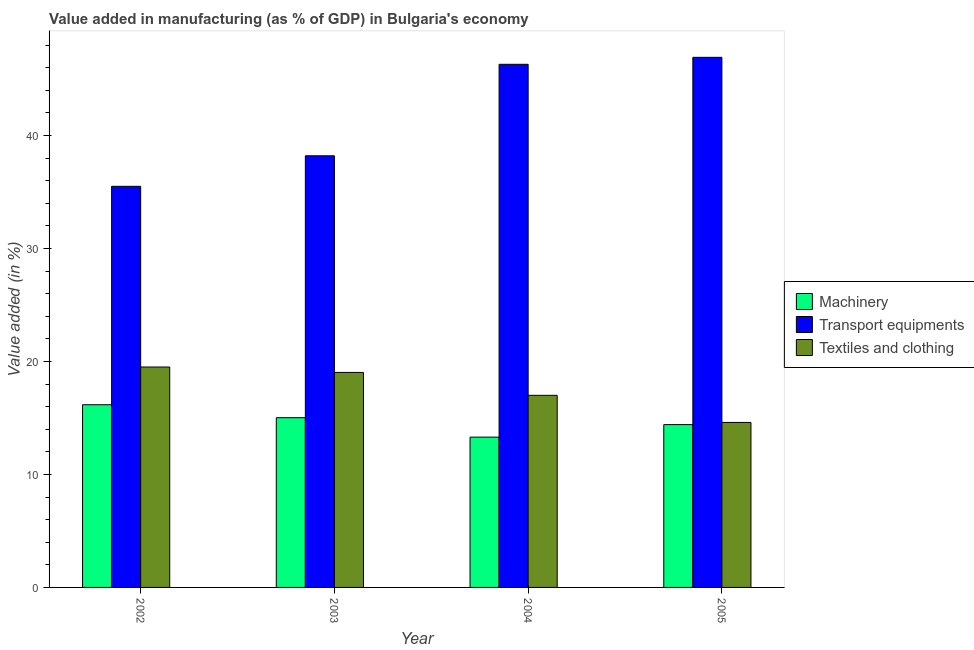Are the number of bars per tick equal to the number of legend labels?
Your response must be concise. Yes. What is the value added in manufacturing transport equipments in 2004?
Provide a succinct answer. 46.3. Across all years, what is the maximum value added in manufacturing transport equipments?
Your answer should be compact. 46.92. Across all years, what is the minimum value added in manufacturing textile and clothing?
Your answer should be compact. 14.6. What is the total value added in manufacturing machinery in the graph?
Provide a short and direct response. 58.9. What is the difference between the value added in manufacturing transport equipments in 2002 and that in 2005?
Your response must be concise. -11.42. What is the difference between the value added in manufacturing textile and clothing in 2003 and the value added in manufacturing machinery in 2005?
Keep it short and to the point. 4.42. What is the average value added in manufacturing transport equipments per year?
Make the answer very short. 41.73. In the year 2002, what is the difference between the value added in manufacturing machinery and value added in manufacturing textile and clothing?
Your answer should be very brief. 0. What is the ratio of the value added in manufacturing transport equipments in 2004 to that in 2005?
Keep it short and to the point. 0.99. What is the difference between the highest and the second highest value added in manufacturing transport equipments?
Provide a succinct answer. 0.62. What is the difference between the highest and the lowest value added in manufacturing transport equipments?
Provide a succinct answer. 11.42. In how many years, is the value added in manufacturing machinery greater than the average value added in manufacturing machinery taken over all years?
Give a very brief answer. 2. Is the sum of the value added in manufacturing machinery in 2003 and 2004 greater than the maximum value added in manufacturing transport equipments across all years?
Offer a terse response. Yes. What does the 1st bar from the left in 2005 represents?
Your answer should be compact. Machinery. What does the 3rd bar from the right in 2005 represents?
Offer a terse response. Machinery. Are all the bars in the graph horizontal?
Offer a terse response. No. How many years are there in the graph?
Make the answer very short. 4. What is the difference between two consecutive major ticks on the Y-axis?
Offer a very short reply. 10. Does the graph contain any zero values?
Keep it short and to the point. No. Where does the legend appear in the graph?
Make the answer very short. Center right. What is the title of the graph?
Your answer should be compact. Value added in manufacturing (as % of GDP) in Bulgaria's economy. Does "Nuclear sources" appear as one of the legend labels in the graph?
Make the answer very short. No. What is the label or title of the X-axis?
Keep it short and to the point. Year. What is the label or title of the Y-axis?
Give a very brief answer. Value added (in %). What is the Value added (in %) in Machinery in 2002?
Give a very brief answer. 16.17. What is the Value added (in %) of Transport equipments in 2002?
Your answer should be very brief. 35.5. What is the Value added (in %) of Textiles and clothing in 2002?
Offer a very short reply. 19.51. What is the Value added (in %) in Machinery in 2003?
Keep it short and to the point. 15.02. What is the Value added (in %) of Transport equipments in 2003?
Keep it short and to the point. 38.2. What is the Value added (in %) of Textiles and clothing in 2003?
Give a very brief answer. 19.03. What is the Value added (in %) of Machinery in 2004?
Offer a very short reply. 13.3. What is the Value added (in %) of Transport equipments in 2004?
Your answer should be compact. 46.3. What is the Value added (in %) in Textiles and clothing in 2004?
Make the answer very short. 17. What is the Value added (in %) of Machinery in 2005?
Give a very brief answer. 14.41. What is the Value added (in %) in Transport equipments in 2005?
Your answer should be compact. 46.92. What is the Value added (in %) in Textiles and clothing in 2005?
Offer a terse response. 14.6. Across all years, what is the maximum Value added (in %) in Machinery?
Keep it short and to the point. 16.17. Across all years, what is the maximum Value added (in %) of Transport equipments?
Offer a terse response. 46.92. Across all years, what is the maximum Value added (in %) in Textiles and clothing?
Provide a succinct answer. 19.51. Across all years, what is the minimum Value added (in %) of Machinery?
Keep it short and to the point. 13.3. Across all years, what is the minimum Value added (in %) of Transport equipments?
Provide a succinct answer. 35.5. Across all years, what is the minimum Value added (in %) in Textiles and clothing?
Provide a short and direct response. 14.6. What is the total Value added (in %) of Machinery in the graph?
Your answer should be compact. 58.9. What is the total Value added (in %) of Transport equipments in the graph?
Your response must be concise. 166.92. What is the total Value added (in %) in Textiles and clothing in the graph?
Your answer should be very brief. 70.14. What is the difference between the Value added (in %) of Machinery in 2002 and that in 2003?
Your answer should be compact. 1.15. What is the difference between the Value added (in %) of Transport equipments in 2002 and that in 2003?
Offer a terse response. -2.7. What is the difference between the Value added (in %) in Textiles and clothing in 2002 and that in 2003?
Make the answer very short. 0.48. What is the difference between the Value added (in %) in Machinery in 2002 and that in 2004?
Offer a very short reply. 2.87. What is the difference between the Value added (in %) in Transport equipments in 2002 and that in 2004?
Ensure brevity in your answer.  -10.8. What is the difference between the Value added (in %) of Textiles and clothing in 2002 and that in 2004?
Offer a very short reply. 2.51. What is the difference between the Value added (in %) of Machinery in 2002 and that in 2005?
Offer a terse response. 1.76. What is the difference between the Value added (in %) in Transport equipments in 2002 and that in 2005?
Make the answer very short. -11.42. What is the difference between the Value added (in %) in Textiles and clothing in 2002 and that in 2005?
Keep it short and to the point. 4.9. What is the difference between the Value added (in %) in Machinery in 2003 and that in 2004?
Your answer should be compact. 1.72. What is the difference between the Value added (in %) in Transport equipments in 2003 and that in 2004?
Keep it short and to the point. -8.1. What is the difference between the Value added (in %) in Textiles and clothing in 2003 and that in 2004?
Offer a very short reply. 2.03. What is the difference between the Value added (in %) in Machinery in 2003 and that in 2005?
Your answer should be very brief. 0.61. What is the difference between the Value added (in %) of Transport equipments in 2003 and that in 2005?
Provide a succinct answer. -8.71. What is the difference between the Value added (in %) of Textiles and clothing in 2003 and that in 2005?
Your answer should be very brief. 4.42. What is the difference between the Value added (in %) in Machinery in 2004 and that in 2005?
Offer a very short reply. -1.11. What is the difference between the Value added (in %) of Transport equipments in 2004 and that in 2005?
Make the answer very short. -0.62. What is the difference between the Value added (in %) in Textiles and clothing in 2004 and that in 2005?
Your answer should be compact. 2.4. What is the difference between the Value added (in %) in Machinery in 2002 and the Value added (in %) in Transport equipments in 2003?
Your response must be concise. -22.03. What is the difference between the Value added (in %) of Machinery in 2002 and the Value added (in %) of Textiles and clothing in 2003?
Your answer should be compact. -2.86. What is the difference between the Value added (in %) of Transport equipments in 2002 and the Value added (in %) of Textiles and clothing in 2003?
Make the answer very short. 16.47. What is the difference between the Value added (in %) in Machinery in 2002 and the Value added (in %) in Transport equipments in 2004?
Offer a terse response. -30.13. What is the difference between the Value added (in %) of Machinery in 2002 and the Value added (in %) of Textiles and clothing in 2004?
Give a very brief answer. -0.83. What is the difference between the Value added (in %) of Transport equipments in 2002 and the Value added (in %) of Textiles and clothing in 2004?
Provide a short and direct response. 18.5. What is the difference between the Value added (in %) in Machinery in 2002 and the Value added (in %) in Transport equipments in 2005?
Your answer should be compact. -30.75. What is the difference between the Value added (in %) in Machinery in 2002 and the Value added (in %) in Textiles and clothing in 2005?
Your answer should be very brief. 1.57. What is the difference between the Value added (in %) of Transport equipments in 2002 and the Value added (in %) of Textiles and clothing in 2005?
Make the answer very short. 20.9. What is the difference between the Value added (in %) of Machinery in 2003 and the Value added (in %) of Transport equipments in 2004?
Your answer should be very brief. -31.28. What is the difference between the Value added (in %) of Machinery in 2003 and the Value added (in %) of Textiles and clothing in 2004?
Your response must be concise. -1.98. What is the difference between the Value added (in %) of Transport equipments in 2003 and the Value added (in %) of Textiles and clothing in 2004?
Make the answer very short. 21.2. What is the difference between the Value added (in %) of Machinery in 2003 and the Value added (in %) of Transport equipments in 2005?
Your answer should be very brief. -31.89. What is the difference between the Value added (in %) in Machinery in 2003 and the Value added (in %) in Textiles and clothing in 2005?
Provide a short and direct response. 0.42. What is the difference between the Value added (in %) in Transport equipments in 2003 and the Value added (in %) in Textiles and clothing in 2005?
Provide a succinct answer. 23.6. What is the difference between the Value added (in %) of Machinery in 2004 and the Value added (in %) of Transport equipments in 2005?
Your answer should be very brief. -33.62. What is the difference between the Value added (in %) in Machinery in 2004 and the Value added (in %) in Textiles and clothing in 2005?
Provide a short and direct response. -1.3. What is the difference between the Value added (in %) in Transport equipments in 2004 and the Value added (in %) in Textiles and clothing in 2005?
Offer a very short reply. 31.7. What is the average Value added (in %) of Machinery per year?
Your answer should be very brief. 14.73. What is the average Value added (in %) in Transport equipments per year?
Keep it short and to the point. 41.73. What is the average Value added (in %) in Textiles and clothing per year?
Give a very brief answer. 17.54. In the year 2002, what is the difference between the Value added (in %) of Machinery and Value added (in %) of Transport equipments?
Keep it short and to the point. -19.33. In the year 2002, what is the difference between the Value added (in %) of Machinery and Value added (in %) of Textiles and clothing?
Your answer should be compact. -3.34. In the year 2002, what is the difference between the Value added (in %) in Transport equipments and Value added (in %) in Textiles and clothing?
Offer a terse response. 15.99. In the year 2003, what is the difference between the Value added (in %) of Machinery and Value added (in %) of Transport equipments?
Your answer should be compact. -23.18. In the year 2003, what is the difference between the Value added (in %) in Machinery and Value added (in %) in Textiles and clothing?
Provide a succinct answer. -4.01. In the year 2003, what is the difference between the Value added (in %) in Transport equipments and Value added (in %) in Textiles and clothing?
Your response must be concise. 19.17. In the year 2004, what is the difference between the Value added (in %) of Machinery and Value added (in %) of Transport equipments?
Ensure brevity in your answer.  -33. In the year 2004, what is the difference between the Value added (in %) of Machinery and Value added (in %) of Textiles and clothing?
Provide a succinct answer. -3.7. In the year 2004, what is the difference between the Value added (in %) in Transport equipments and Value added (in %) in Textiles and clothing?
Offer a very short reply. 29.3. In the year 2005, what is the difference between the Value added (in %) in Machinery and Value added (in %) in Transport equipments?
Keep it short and to the point. -32.51. In the year 2005, what is the difference between the Value added (in %) of Machinery and Value added (in %) of Textiles and clothing?
Offer a very short reply. -0.19. In the year 2005, what is the difference between the Value added (in %) of Transport equipments and Value added (in %) of Textiles and clothing?
Ensure brevity in your answer.  32.31. What is the ratio of the Value added (in %) of Machinery in 2002 to that in 2003?
Provide a succinct answer. 1.08. What is the ratio of the Value added (in %) of Transport equipments in 2002 to that in 2003?
Provide a short and direct response. 0.93. What is the ratio of the Value added (in %) of Textiles and clothing in 2002 to that in 2003?
Your response must be concise. 1.03. What is the ratio of the Value added (in %) of Machinery in 2002 to that in 2004?
Make the answer very short. 1.22. What is the ratio of the Value added (in %) of Transport equipments in 2002 to that in 2004?
Your response must be concise. 0.77. What is the ratio of the Value added (in %) in Textiles and clothing in 2002 to that in 2004?
Your answer should be very brief. 1.15. What is the ratio of the Value added (in %) of Machinery in 2002 to that in 2005?
Give a very brief answer. 1.12. What is the ratio of the Value added (in %) of Transport equipments in 2002 to that in 2005?
Provide a succinct answer. 0.76. What is the ratio of the Value added (in %) of Textiles and clothing in 2002 to that in 2005?
Give a very brief answer. 1.34. What is the ratio of the Value added (in %) in Machinery in 2003 to that in 2004?
Provide a short and direct response. 1.13. What is the ratio of the Value added (in %) in Transport equipments in 2003 to that in 2004?
Provide a short and direct response. 0.83. What is the ratio of the Value added (in %) of Textiles and clothing in 2003 to that in 2004?
Keep it short and to the point. 1.12. What is the ratio of the Value added (in %) of Machinery in 2003 to that in 2005?
Offer a very short reply. 1.04. What is the ratio of the Value added (in %) in Transport equipments in 2003 to that in 2005?
Make the answer very short. 0.81. What is the ratio of the Value added (in %) of Textiles and clothing in 2003 to that in 2005?
Keep it short and to the point. 1.3. What is the ratio of the Value added (in %) in Machinery in 2004 to that in 2005?
Your answer should be very brief. 0.92. What is the ratio of the Value added (in %) of Transport equipments in 2004 to that in 2005?
Offer a very short reply. 0.99. What is the ratio of the Value added (in %) of Textiles and clothing in 2004 to that in 2005?
Provide a short and direct response. 1.16. What is the difference between the highest and the second highest Value added (in %) in Machinery?
Give a very brief answer. 1.15. What is the difference between the highest and the second highest Value added (in %) in Transport equipments?
Offer a terse response. 0.62. What is the difference between the highest and the second highest Value added (in %) in Textiles and clothing?
Give a very brief answer. 0.48. What is the difference between the highest and the lowest Value added (in %) in Machinery?
Keep it short and to the point. 2.87. What is the difference between the highest and the lowest Value added (in %) in Transport equipments?
Offer a very short reply. 11.42. What is the difference between the highest and the lowest Value added (in %) of Textiles and clothing?
Ensure brevity in your answer.  4.9. 